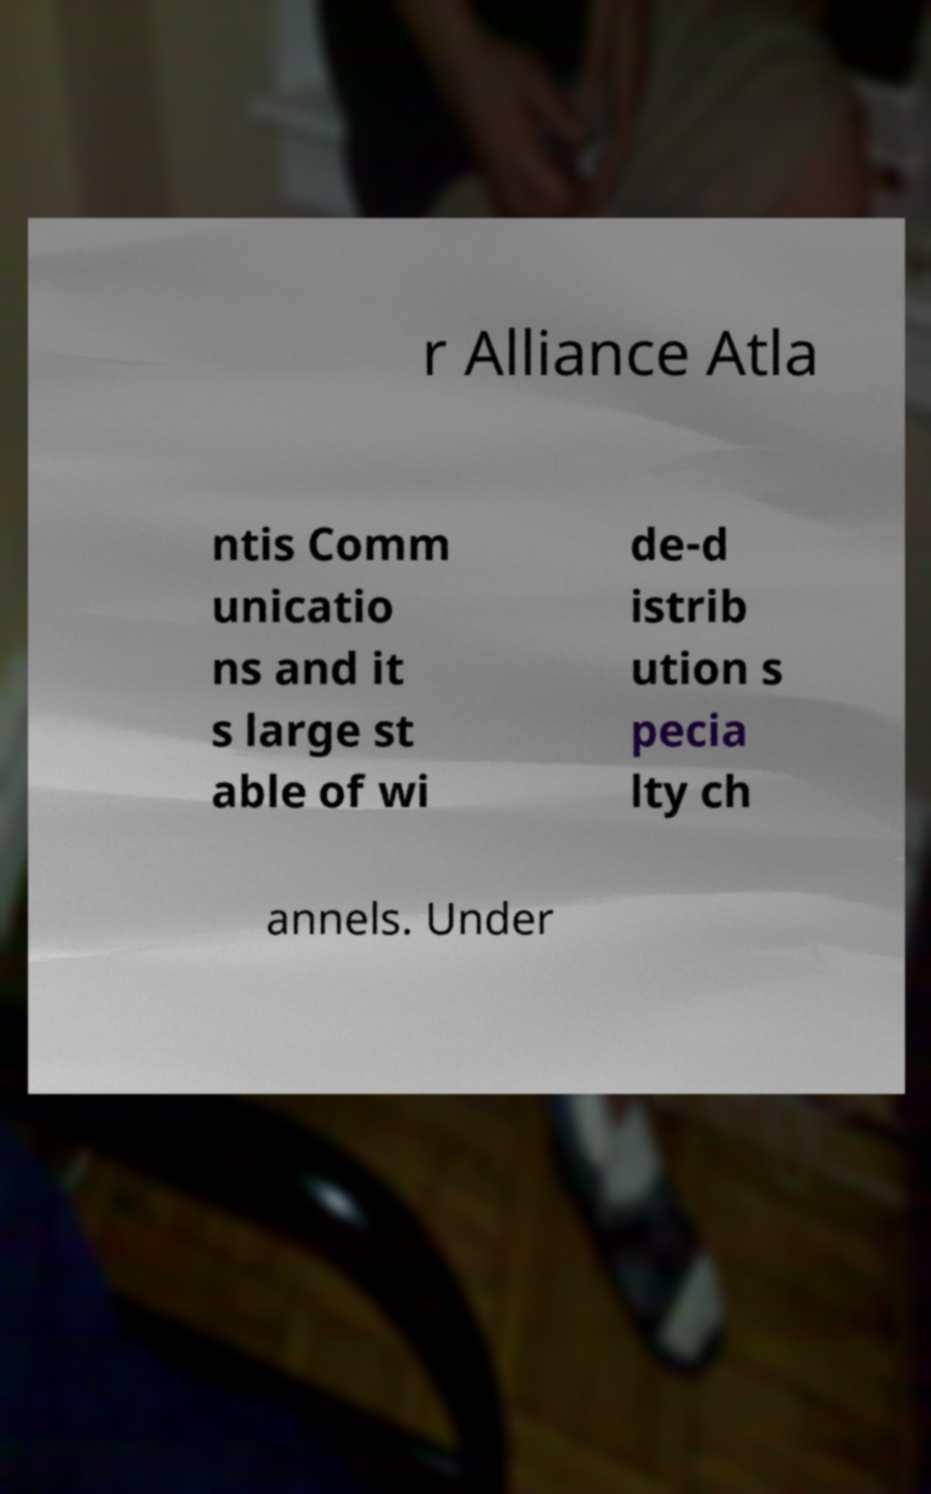Could you extract and type out the text from this image? r Alliance Atla ntis Comm unicatio ns and it s large st able of wi de-d istrib ution s pecia lty ch annels. Under 